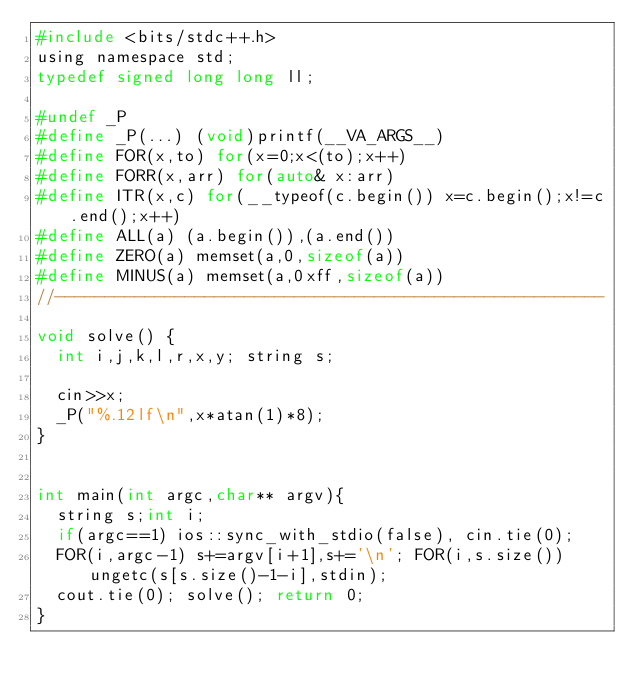Convert code to text. <code><loc_0><loc_0><loc_500><loc_500><_C_>#include <bits/stdc++.h>
using namespace std;
typedef signed long long ll;

#undef _P
#define _P(...) (void)printf(__VA_ARGS__)
#define FOR(x,to) for(x=0;x<(to);x++)
#define FORR(x,arr) for(auto& x:arr)
#define ITR(x,c) for(__typeof(c.begin()) x=c.begin();x!=c.end();x++)
#define ALL(a) (a.begin()),(a.end())
#define ZERO(a) memset(a,0,sizeof(a))
#define MINUS(a) memset(a,0xff,sizeof(a))
//-------------------------------------------------------

void solve() {
	int i,j,k,l,r,x,y; string s;
	
	cin>>x;
	_P("%.12lf\n",x*atan(1)*8);
}


int main(int argc,char** argv){
	string s;int i;
	if(argc==1) ios::sync_with_stdio(false), cin.tie(0);
	FOR(i,argc-1) s+=argv[i+1],s+='\n'; FOR(i,s.size()) ungetc(s[s.size()-1-i],stdin);
	cout.tie(0); solve(); return 0;
}
</code> 